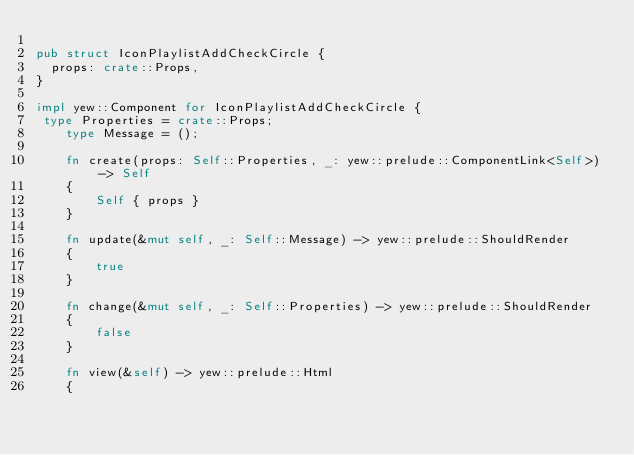Convert code to text. <code><loc_0><loc_0><loc_500><loc_500><_Rust_>
pub struct IconPlaylistAddCheckCircle {
  props: crate::Props,
}

impl yew::Component for IconPlaylistAddCheckCircle {
 type Properties = crate::Props;
    type Message = ();

    fn create(props: Self::Properties, _: yew::prelude::ComponentLink<Self>) -> Self
    {
        Self { props }
    }

    fn update(&mut self, _: Self::Message) -> yew::prelude::ShouldRender
    {
        true
    }

    fn change(&mut self, _: Self::Properties) -> yew::prelude::ShouldRender
    {
        false
    }

    fn view(&self) -> yew::prelude::Html
    {</code> 